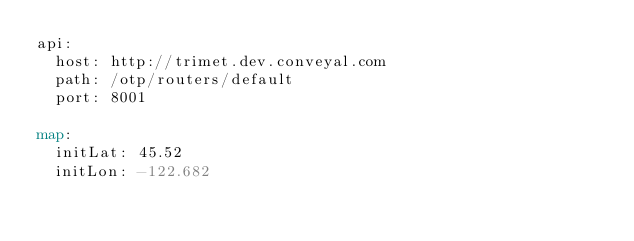<code> <loc_0><loc_0><loc_500><loc_500><_YAML_>api:
  host: http://trimet.dev.conveyal.com
  path: /otp/routers/default
  port: 8001

map:
  initLat: 45.52
  initLon: -122.682
</code> 